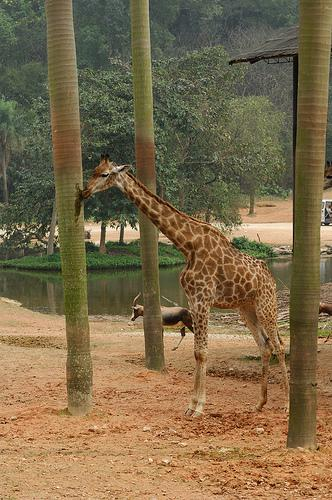Question: how many animals are there?
Choices:
A. 1.
B. 2.
C. 5.
D. 3.
Answer with the letter. Answer: B Question: how many people are with them?
Choices:
A. One.
B. Two.
C. Three.
D. No one.
Answer with the letter. Answer: D Question: what is the color of the leaves?
Choices:
A. Yellow.
B. Orange.
C. Brown.
D. Green.
Answer with the letter. Answer: D Question: where was the picture teken?
Choices:
A. In a zoo.
B. The beach.
C. A musuem.
D. Field.
Answer with the letter. Answer: A 